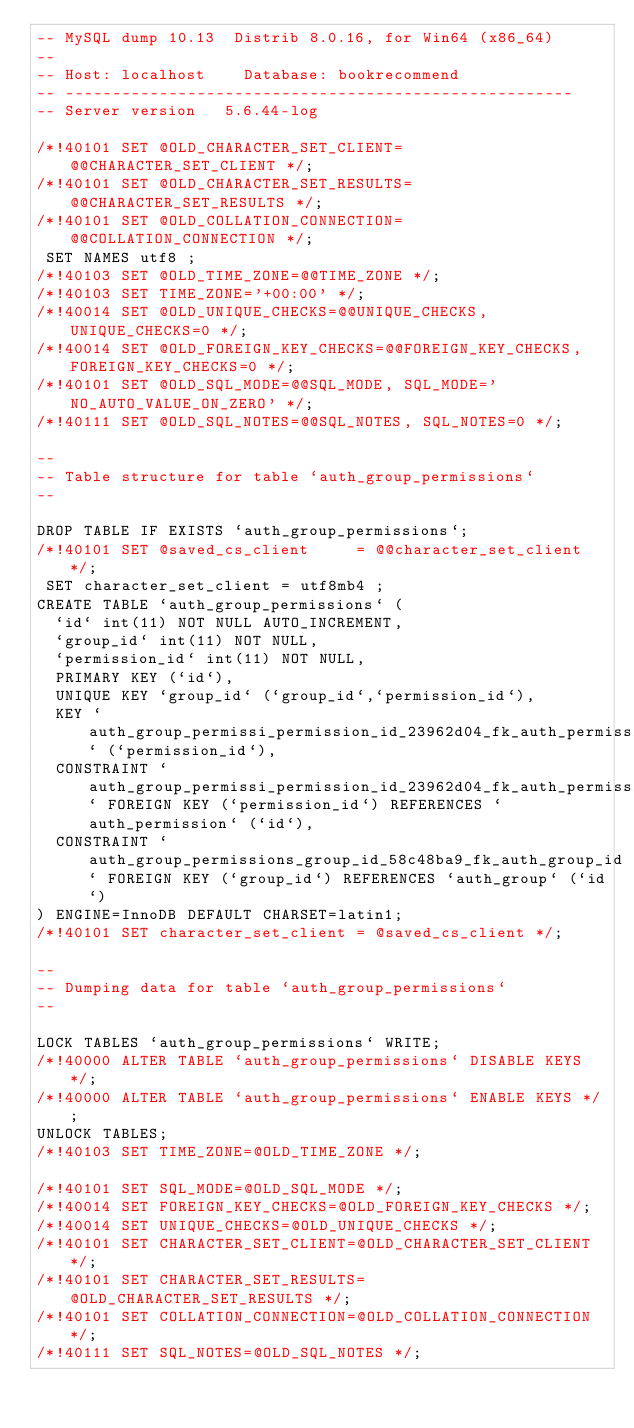<code> <loc_0><loc_0><loc_500><loc_500><_SQL_>-- MySQL dump 10.13  Distrib 8.0.16, for Win64 (x86_64)
--
-- Host: localhost    Database: bookrecommend
-- ------------------------------------------------------
-- Server version	5.6.44-log

/*!40101 SET @OLD_CHARACTER_SET_CLIENT=@@CHARACTER_SET_CLIENT */;
/*!40101 SET @OLD_CHARACTER_SET_RESULTS=@@CHARACTER_SET_RESULTS */;
/*!40101 SET @OLD_COLLATION_CONNECTION=@@COLLATION_CONNECTION */;
 SET NAMES utf8 ;
/*!40103 SET @OLD_TIME_ZONE=@@TIME_ZONE */;
/*!40103 SET TIME_ZONE='+00:00' */;
/*!40014 SET @OLD_UNIQUE_CHECKS=@@UNIQUE_CHECKS, UNIQUE_CHECKS=0 */;
/*!40014 SET @OLD_FOREIGN_KEY_CHECKS=@@FOREIGN_KEY_CHECKS, FOREIGN_KEY_CHECKS=0 */;
/*!40101 SET @OLD_SQL_MODE=@@SQL_MODE, SQL_MODE='NO_AUTO_VALUE_ON_ZERO' */;
/*!40111 SET @OLD_SQL_NOTES=@@SQL_NOTES, SQL_NOTES=0 */;

--
-- Table structure for table `auth_group_permissions`
--

DROP TABLE IF EXISTS `auth_group_permissions`;
/*!40101 SET @saved_cs_client     = @@character_set_client */;
 SET character_set_client = utf8mb4 ;
CREATE TABLE `auth_group_permissions` (
  `id` int(11) NOT NULL AUTO_INCREMENT,
  `group_id` int(11) NOT NULL,
  `permission_id` int(11) NOT NULL,
  PRIMARY KEY (`id`),
  UNIQUE KEY `group_id` (`group_id`,`permission_id`),
  KEY `auth_group_permissi_permission_id_23962d04_fk_auth_permission_id` (`permission_id`),
  CONSTRAINT `auth_group_permissi_permission_id_23962d04_fk_auth_permission_id` FOREIGN KEY (`permission_id`) REFERENCES `auth_permission` (`id`),
  CONSTRAINT `auth_group_permissions_group_id_58c48ba9_fk_auth_group_id` FOREIGN KEY (`group_id`) REFERENCES `auth_group` (`id`)
) ENGINE=InnoDB DEFAULT CHARSET=latin1;
/*!40101 SET character_set_client = @saved_cs_client */;

--
-- Dumping data for table `auth_group_permissions`
--

LOCK TABLES `auth_group_permissions` WRITE;
/*!40000 ALTER TABLE `auth_group_permissions` DISABLE KEYS */;
/*!40000 ALTER TABLE `auth_group_permissions` ENABLE KEYS */;
UNLOCK TABLES;
/*!40103 SET TIME_ZONE=@OLD_TIME_ZONE */;

/*!40101 SET SQL_MODE=@OLD_SQL_MODE */;
/*!40014 SET FOREIGN_KEY_CHECKS=@OLD_FOREIGN_KEY_CHECKS */;
/*!40014 SET UNIQUE_CHECKS=@OLD_UNIQUE_CHECKS */;
/*!40101 SET CHARACTER_SET_CLIENT=@OLD_CHARACTER_SET_CLIENT */;
/*!40101 SET CHARACTER_SET_RESULTS=@OLD_CHARACTER_SET_RESULTS */;
/*!40101 SET COLLATION_CONNECTION=@OLD_COLLATION_CONNECTION */;
/*!40111 SET SQL_NOTES=@OLD_SQL_NOTES */;
</code> 